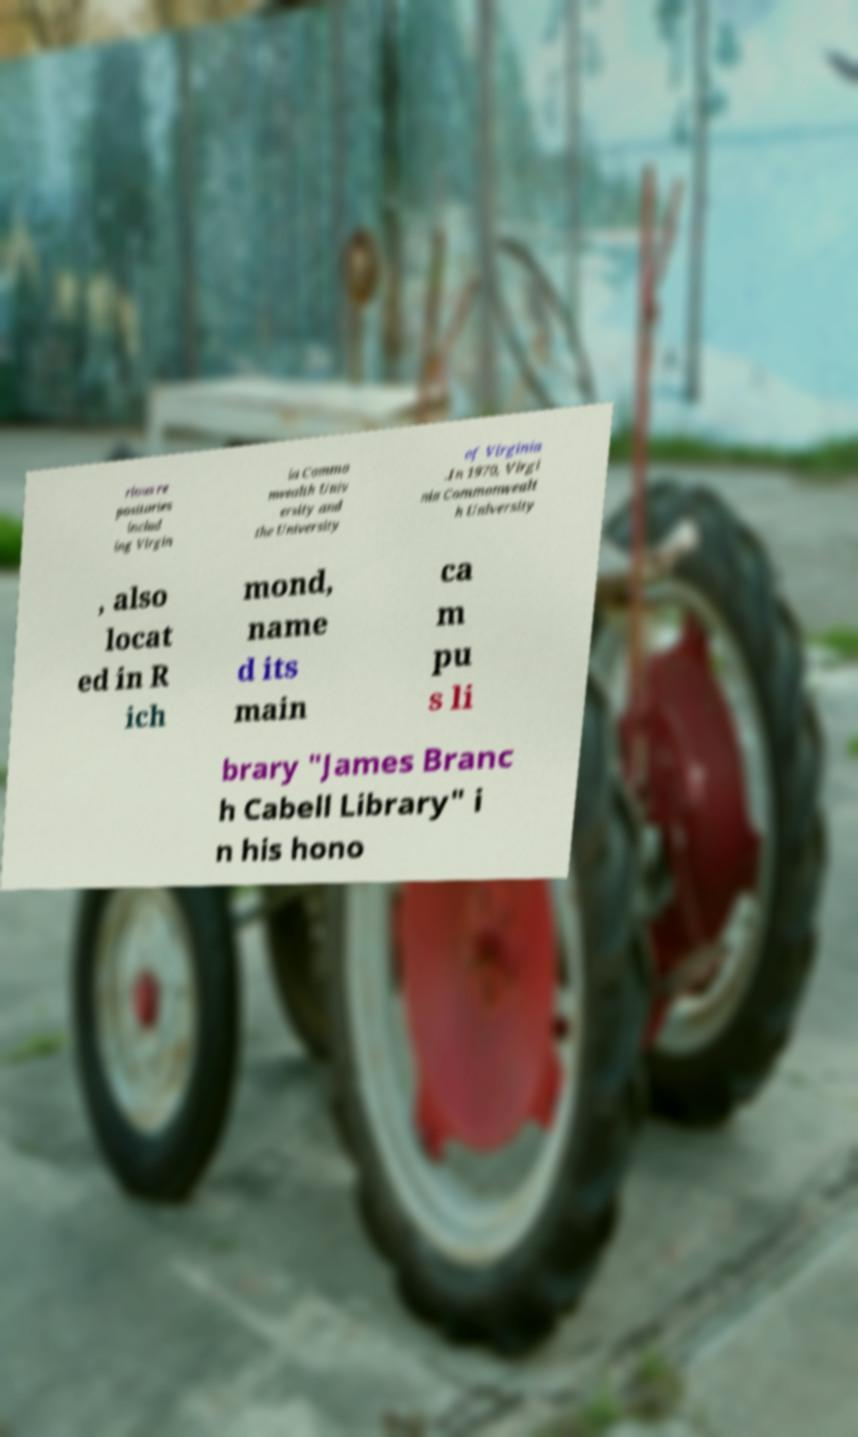Can you accurately transcribe the text from the provided image for me? rious re positories includ ing Virgin ia Commo nwealth Univ ersity and the University of Virginia .In 1970, Virgi nia Commonwealt h University , also locat ed in R ich mond, name d its main ca m pu s li brary "James Branc h Cabell Library" i n his hono 